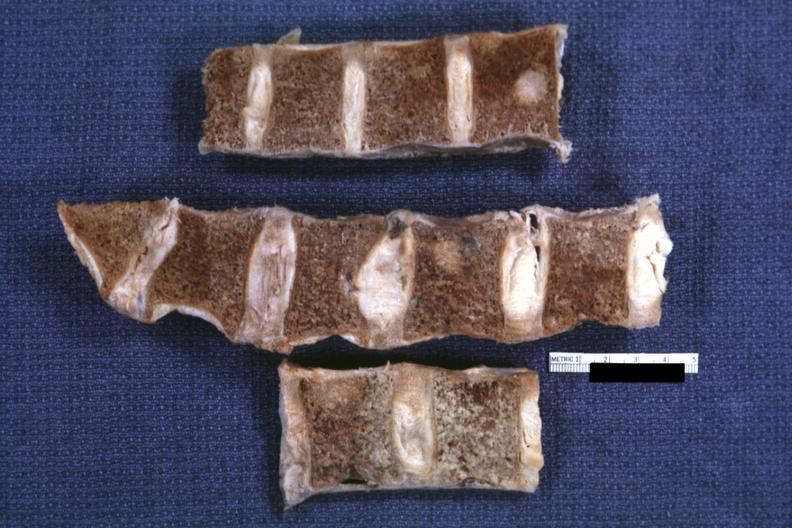does this image show fixed tissue well shown lesion in vertebral marrow lung adenoca?
Answer the question using a single word or phrase. Yes 